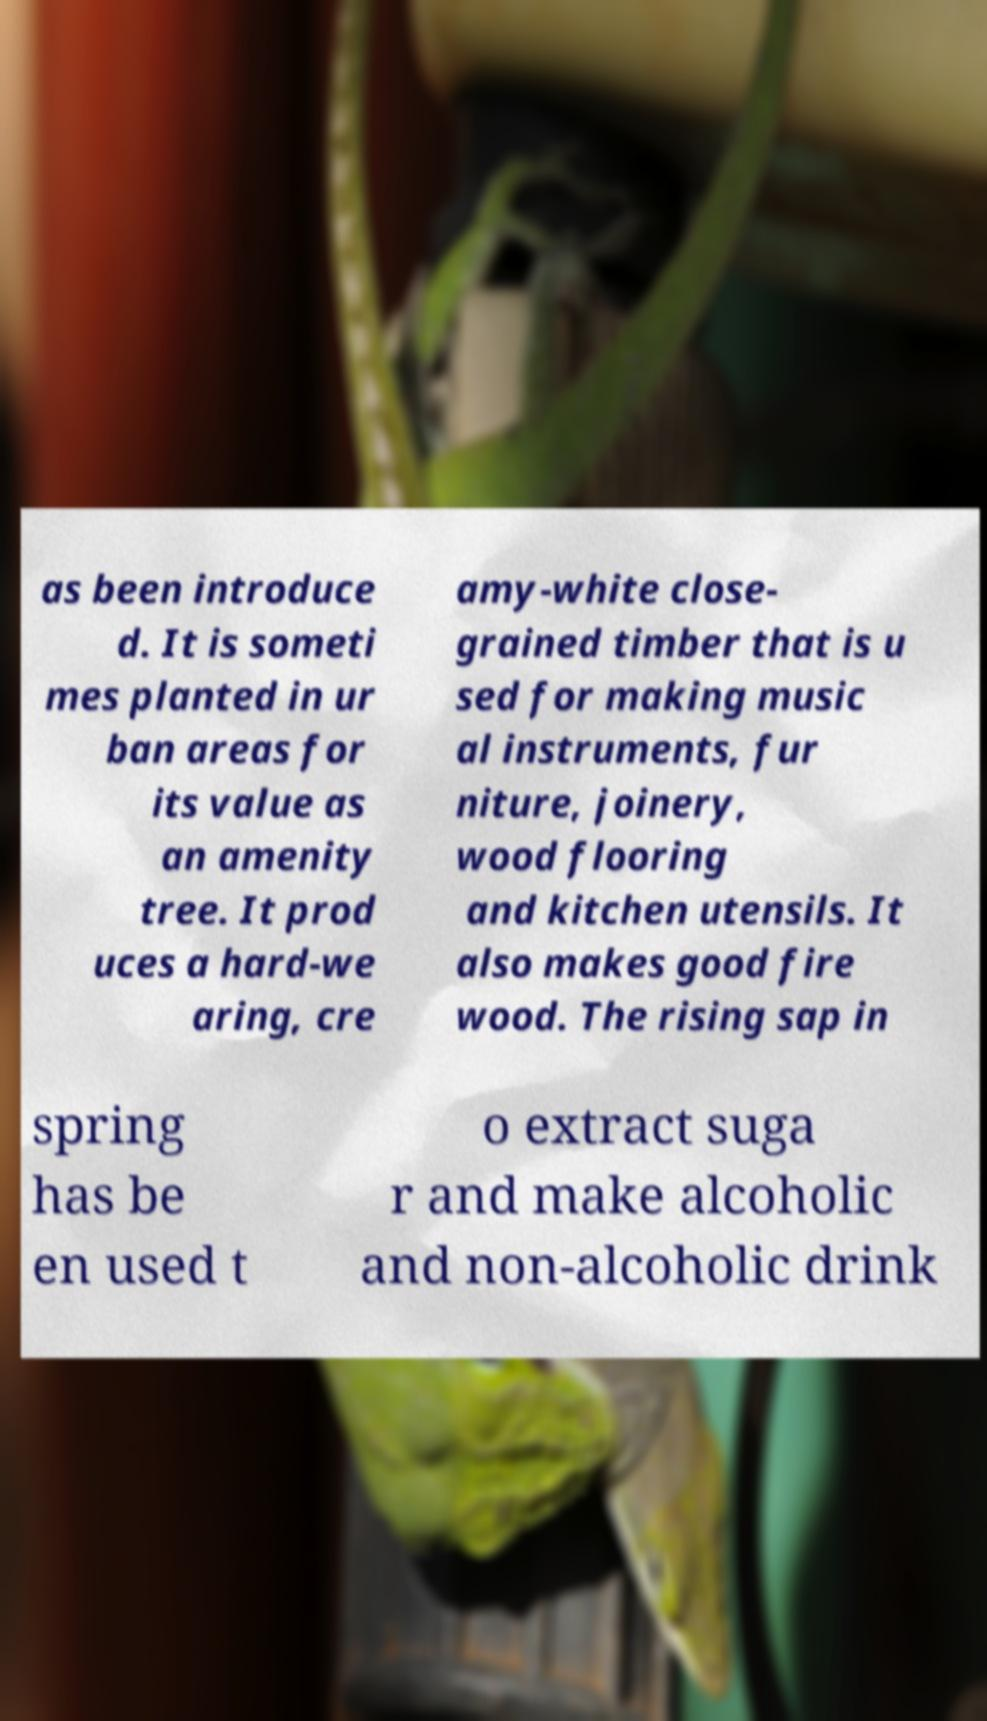There's text embedded in this image that I need extracted. Can you transcribe it verbatim? as been introduce d. It is someti mes planted in ur ban areas for its value as an amenity tree. It prod uces a hard-we aring, cre amy-white close- grained timber that is u sed for making music al instruments, fur niture, joinery, wood flooring and kitchen utensils. It also makes good fire wood. The rising sap in spring has be en used t o extract suga r and make alcoholic and non-alcoholic drink 